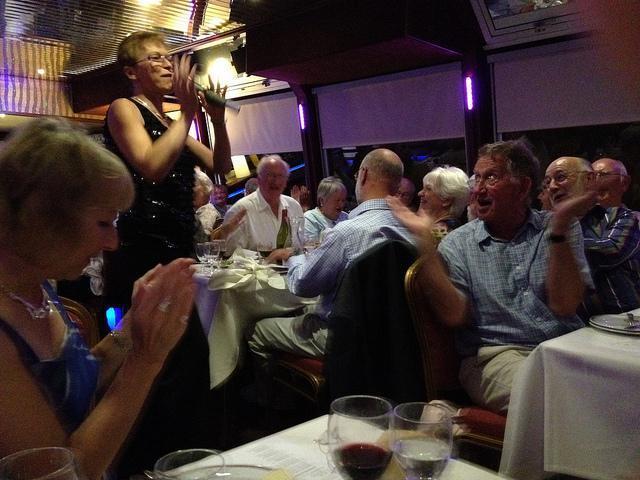How many chairs are there?
Give a very brief answer. 2. How many wine glasses can be seen?
Give a very brief answer. 3. How many tvs can be seen?
Give a very brief answer. 2. How many people are there?
Give a very brief answer. 8. How many dining tables are there?
Give a very brief answer. 3. How many cars are between the trees?
Give a very brief answer. 0. 